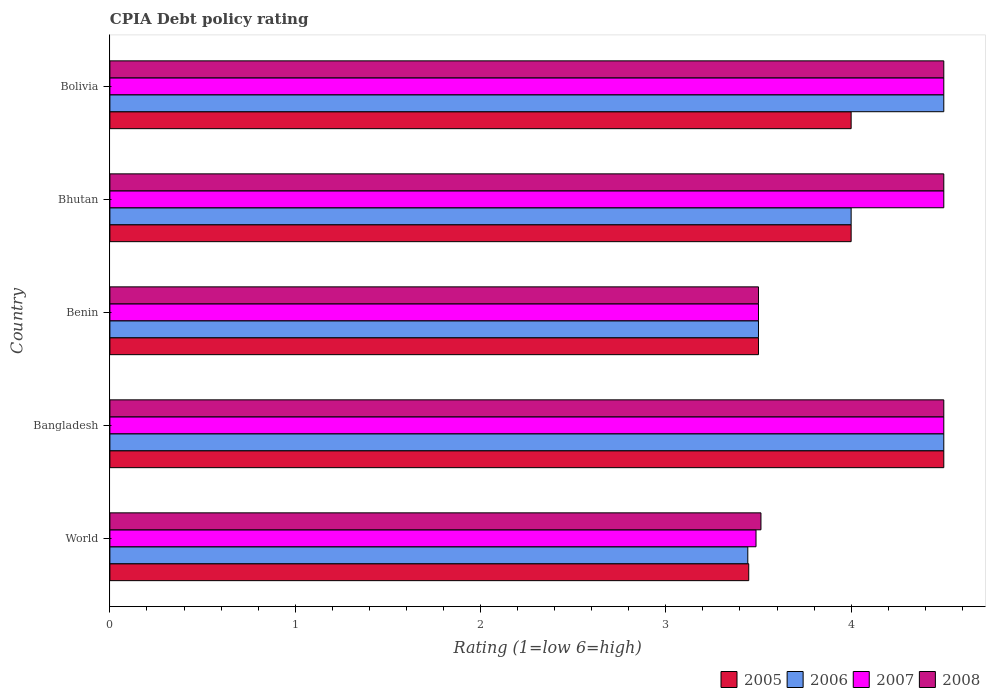How many bars are there on the 4th tick from the bottom?
Make the answer very short. 4. What is the label of the 3rd group of bars from the top?
Offer a very short reply. Benin. Across all countries, what is the minimum CPIA rating in 2005?
Keep it short and to the point. 3.45. In which country was the CPIA rating in 2008 maximum?
Ensure brevity in your answer.  Bangladesh. In which country was the CPIA rating in 2007 minimum?
Ensure brevity in your answer.  World. What is the total CPIA rating in 2007 in the graph?
Ensure brevity in your answer.  20.49. What is the difference between the CPIA rating in 2006 in Benin and that in World?
Offer a terse response. 0.06. What is the difference between the CPIA rating in 2005 in Bangladesh and the CPIA rating in 2007 in World?
Your response must be concise. 1.01. What is the average CPIA rating in 2006 per country?
Your answer should be compact. 3.99. Is the difference between the CPIA rating in 2006 in Bangladesh and Bolivia greater than the difference between the CPIA rating in 2005 in Bangladesh and Bolivia?
Provide a short and direct response. No. What is the difference between the highest and the lowest CPIA rating in 2008?
Offer a terse response. 1. In how many countries, is the CPIA rating in 2005 greater than the average CPIA rating in 2005 taken over all countries?
Make the answer very short. 3. What does the 1st bar from the top in Bangladesh represents?
Give a very brief answer. 2008. Is it the case that in every country, the sum of the CPIA rating in 2008 and CPIA rating in 2005 is greater than the CPIA rating in 2006?
Your answer should be compact. Yes. Are all the bars in the graph horizontal?
Make the answer very short. Yes. How many countries are there in the graph?
Your answer should be very brief. 5. Are the values on the major ticks of X-axis written in scientific E-notation?
Make the answer very short. No. Does the graph contain any zero values?
Offer a very short reply. No. How many legend labels are there?
Your response must be concise. 4. How are the legend labels stacked?
Your answer should be compact. Horizontal. What is the title of the graph?
Your answer should be compact. CPIA Debt policy rating. What is the Rating (1=low 6=high) in 2005 in World?
Your answer should be compact. 3.45. What is the Rating (1=low 6=high) of 2006 in World?
Provide a succinct answer. 3.44. What is the Rating (1=low 6=high) of 2007 in World?
Offer a terse response. 3.49. What is the Rating (1=low 6=high) in 2008 in World?
Your answer should be very brief. 3.51. What is the Rating (1=low 6=high) of 2005 in Bangladesh?
Provide a short and direct response. 4.5. What is the Rating (1=low 6=high) of 2006 in Bangladesh?
Offer a very short reply. 4.5. What is the Rating (1=low 6=high) in 2008 in Bangladesh?
Provide a succinct answer. 4.5. What is the Rating (1=low 6=high) in 2008 in Benin?
Your answer should be compact. 3.5. What is the Rating (1=low 6=high) of 2005 in Bhutan?
Provide a succinct answer. 4. What is the Rating (1=low 6=high) in 2008 in Bhutan?
Your response must be concise. 4.5. What is the Rating (1=low 6=high) in 2005 in Bolivia?
Your response must be concise. 4. What is the Rating (1=low 6=high) of 2006 in Bolivia?
Provide a succinct answer. 4.5. What is the Rating (1=low 6=high) of 2007 in Bolivia?
Your answer should be very brief. 4.5. Across all countries, what is the maximum Rating (1=low 6=high) of 2005?
Your answer should be very brief. 4.5. Across all countries, what is the maximum Rating (1=low 6=high) in 2007?
Your answer should be very brief. 4.5. Across all countries, what is the minimum Rating (1=low 6=high) in 2005?
Offer a very short reply. 3.45. Across all countries, what is the minimum Rating (1=low 6=high) of 2006?
Your answer should be compact. 3.44. Across all countries, what is the minimum Rating (1=low 6=high) in 2007?
Your answer should be very brief. 3.49. Across all countries, what is the minimum Rating (1=low 6=high) in 2008?
Keep it short and to the point. 3.5. What is the total Rating (1=low 6=high) of 2005 in the graph?
Your answer should be very brief. 19.45. What is the total Rating (1=low 6=high) of 2006 in the graph?
Offer a very short reply. 19.94. What is the total Rating (1=low 6=high) in 2007 in the graph?
Offer a terse response. 20.49. What is the total Rating (1=low 6=high) in 2008 in the graph?
Provide a succinct answer. 20.51. What is the difference between the Rating (1=low 6=high) of 2005 in World and that in Bangladesh?
Your response must be concise. -1.05. What is the difference between the Rating (1=low 6=high) of 2006 in World and that in Bangladesh?
Ensure brevity in your answer.  -1.06. What is the difference between the Rating (1=low 6=high) in 2007 in World and that in Bangladesh?
Give a very brief answer. -1.01. What is the difference between the Rating (1=low 6=high) of 2008 in World and that in Bangladesh?
Offer a very short reply. -0.99. What is the difference between the Rating (1=low 6=high) of 2005 in World and that in Benin?
Offer a terse response. -0.05. What is the difference between the Rating (1=low 6=high) in 2006 in World and that in Benin?
Offer a terse response. -0.06. What is the difference between the Rating (1=low 6=high) of 2007 in World and that in Benin?
Offer a terse response. -0.01. What is the difference between the Rating (1=low 6=high) in 2008 in World and that in Benin?
Keep it short and to the point. 0.01. What is the difference between the Rating (1=low 6=high) of 2005 in World and that in Bhutan?
Your answer should be compact. -0.55. What is the difference between the Rating (1=low 6=high) in 2006 in World and that in Bhutan?
Give a very brief answer. -0.56. What is the difference between the Rating (1=low 6=high) of 2007 in World and that in Bhutan?
Ensure brevity in your answer.  -1.01. What is the difference between the Rating (1=low 6=high) of 2008 in World and that in Bhutan?
Your answer should be very brief. -0.99. What is the difference between the Rating (1=low 6=high) of 2005 in World and that in Bolivia?
Your answer should be very brief. -0.55. What is the difference between the Rating (1=low 6=high) of 2006 in World and that in Bolivia?
Your response must be concise. -1.06. What is the difference between the Rating (1=low 6=high) of 2007 in World and that in Bolivia?
Ensure brevity in your answer.  -1.01. What is the difference between the Rating (1=low 6=high) in 2008 in World and that in Bolivia?
Your answer should be compact. -0.99. What is the difference between the Rating (1=low 6=high) in 2006 in Bangladesh and that in Benin?
Your response must be concise. 1. What is the difference between the Rating (1=low 6=high) of 2006 in Bangladesh and that in Bhutan?
Provide a succinct answer. 0.5. What is the difference between the Rating (1=low 6=high) of 2007 in Bangladesh and that in Bhutan?
Give a very brief answer. 0. What is the difference between the Rating (1=low 6=high) of 2008 in Bangladesh and that in Bhutan?
Provide a short and direct response. 0. What is the difference between the Rating (1=low 6=high) of 2005 in Bangladesh and that in Bolivia?
Offer a terse response. 0.5. What is the difference between the Rating (1=low 6=high) of 2005 in Benin and that in Bhutan?
Keep it short and to the point. -0.5. What is the difference between the Rating (1=low 6=high) in 2006 in Benin and that in Bhutan?
Give a very brief answer. -0.5. What is the difference between the Rating (1=low 6=high) in 2007 in Benin and that in Bhutan?
Keep it short and to the point. -1. What is the difference between the Rating (1=low 6=high) in 2006 in Benin and that in Bolivia?
Give a very brief answer. -1. What is the difference between the Rating (1=low 6=high) of 2006 in Bhutan and that in Bolivia?
Make the answer very short. -0.5. What is the difference between the Rating (1=low 6=high) of 2007 in Bhutan and that in Bolivia?
Give a very brief answer. 0. What is the difference between the Rating (1=low 6=high) in 2005 in World and the Rating (1=low 6=high) in 2006 in Bangladesh?
Your response must be concise. -1.05. What is the difference between the Rating (1=low 6=high) of 2005 in World and the Rating (1=low 6=high) of 2007 in Bangladesh?
Provide a short and direct response. -1.05. What is the difference between the Rating (1=low 6=high) of 2005 in World and the Rating (1=low 6=high) of 2008 in Bangladesh?
Your response must be concise. -1.05. What is the difference between the Rating (1=low 6=high) of 2006 in World and the Rating (1=low 6=high) of 2007 in Bangladesh?
Provide a short and direct response. -1.06. What is the difference between the Rating (1=low 6=high) in 2006 in World and the Rating (1=low 6=high) in 2008 in Bangladesh?
Give a very brief answer. -1.06. What is the difference between the Rating (1=low 6=high) of 2007 in World and the Rating (1=low 6=high) of 2008 in Bangladesh?
Your answer should be compact. -1.01. What is the difference between the Rating (1=low 6=high) in 2005 in World and the Rating (1=low 6=high) in 2006 in Benin?
Your answer should be compact. -0.05. What is the difference between the Rating (1=low 6=high) of 2005 in World and the Rating (1=low 6=high) of 2007 in Benin?
Your response must be concise. -0.05. What is the difference between the Rating (1=low 6=high) in 2005 in World and the Rating (1=low 6=high) in 2008 in Benin?
Offer a terse response. -0.05. What is the difference between the Rating (1=low 6=high) in 2006 in World and the Rating (1=low 6=high) in 2007 in Benin?
Provide a short and direct response. -0.06. What is the difference between the Rating (1=low 6=high) in 2006 in World and the Rating (1=low 6=high) in 2008 in Benin?
Make the answer very short. -0.06. What is the difference between the Rating (1=low 6=high) of 2007 in World and the Rating (1=low 6=high) of 2008 in Benin?
Your answer should be very brief. -0.01. What is the difference between the Rating (1=low 6=high) in 2005 in World and the Rating (1=low 6=high) in 2006 in Bhutan?
Your response must be concise. -0.55. What is the difference between the Rating (1=low 6=high) of 2005 in World and the Rating (1=low 6=high) of 2007 in Bhutan?
Make the answer very short. -1.05. What is the difference between the Rating (1=low 6=high) in 2005 in World and the Rating (1=low 6=high) in 2008 in Bhutan?
Ensure brevity in your answer.  -1.05. What is the difference between the Rating (1=low 6=high) of 2006 in World and the Rating (1=low 6=high) of 2007 in Bhutan?
Provide a succinct answer. -1.06. What is the difference between the Rating (1=low 6=high) of 2006 in World and the Rating (1=low 6=high) of 2008 in Bhutan?
Provide a succinct answer. -1.06. What is the difference between the Rating (1=low 6=high) of 2007 in World and the Rating (1=low 6=high) of 2008 in Bhutan?
Your answer should be compact. -1.01. What is the difference between the Rating (1=low 6=high) of 2005 in World and the Rating (1=low 6=high) of 2006 in Bolivia?
Provide a succinct answer. -1.05. What is the difference between the Rating (1=low 6=high) in 2005 in World and the Rating (1=low 6=high) in 2007 in Bolivia?
Give a very brief answer. -1.05. What is the difference between the Rating (1=low 6=high) in 2005 in World and the Rating (1=low 6=high) in 2008 in Bolivia?
Provide a succinct answer. -1.05. What is the difference between the Rating (1=low 6=high) of 2006 in World and the Rating (1=low 6=high) of 2007 in Bolivia?
Keep it short and to the point. -1.06. What is the difference between the Rating (1=low 6=high) in 2006 in World and the Rating (1=low 6=high) in 2008 in Bolivia?
Keep it short and to the point. -1.06. What is the difference between the Rating (1=low 6=high) in 2007 in World and the Rating (1=low 6=high) in 2008 in Bolivia?
Ensure brevity in your answer.  -1.01. What is the difference between the Rating (1=low 6=high) in 2005 in Bangladesh and the Rating (1=low 6=high) in 2006 in Benin?
Offer a terse response. 1. What is the difference between the Rating (1=low 6=high) in 2005 in Bangladesh and the Rating (1=low 6=high) in 2007 in Benin?
Ensure brevity in your answer.  1. What is the difference between the Rating (1=low 6=high) of 2006 in Bangladesh and the Rating (1=low 6=high) of 2007 in Benin?
Your answer should be very brief. 1. What is the difference between the Rating (1=low 6=high) in 2005 in Bangladesh and the Rating (1=low 6=high) in 2007 in Bhutan?
Provide a succinct answer. 0. What is the difference between the Rating (1=low 6=high) of 2005 in Bangladesh and the Rating (1=low 6=high) of 2008 in Bhutan?
Provide a succinct answer. 0. What is the difference between the Rating (1=low 6=high) of 2007 in Bangladesh and the Rating (1=low 6=high) of 2008 in Bhutan?
Your response must be concise. 0. What is the difference between the Rating (1=low 6=high) of 2005 in Bangladesh and the Rating (1=low 6=high) of 2008 in Bolivia?
Keep it short and to the point. 0. What is the difference between the Rating (1=low 6=high) in 2006 in Bangladesh and the Rating (1=low 6=high) in 2007 in Bolivia?
Your answer should be compact. 0. What is the difference between the Rating (1=low 6=high) in 2006 in Bangladesh and the Rating (1=low 6=high) in 2008 in Bolivia?
Provide a short and direct response. 0. What is the difference between the Rating (1=low 6=high) in 2005 in Benin and the Rating (1=low 6=high) in 2006 in Bhutan?
Your response must be concise. -0.5. What is the difference between the Rating (1=low 6=high) of 2005 in Benin and the Rating (1=low 6=high) of 2007 in Bhutan?
Make the answer very short. -1. What is the difference between the Rating (1=low 6=high) of 2005 in Benin and the Rating (1=low 6=high) of 2008 in Bhutan?
Offer a very short reply. -1. What is the difference between the Rating (1=low 6=high) of 2007 in Benin and the Rating (1=low 6=high) of 2008 in Bhutan?
Your answer should be compact. -1. What is the difference between the Rating (1=low 6=high) of 2005 in Benin and the Rating (1=low 6=high) of 2007 in Bolivia?
Your response must be concise. -1. What is the difference between the Rating (1=low 6=high) in 2005 in Benin and the Rating (1=low 6=high) in 2008 in Bolivia?
Give a very brief answer. -1. What is the difference between the Rating (1=low 6=high) in 2007 in Benin and the Rating (1=low 6=high) in 2008 in Bolivia?
Your answer should be very brief. -1. What is the difference between the Rating (1=low 6=high) in 2005 in Bhutan and the Rating (1=low 6=high) in 2006 in Bolivia?
Offer a terse response. -0.5. What is the difference between the Rating (1=low 6=high) in 2005 in Bhutan and the Rating (1=low 6=high) in 2007 in Bolivia?
Make the answer very short. -0.5. What is the difference between the Rating (1=low 6=high) in 2005 in Bhutan and the Rating (1=low 6=high) in 2008 in Bolivia?
Your answer should be very brief. -0.5. What is the difference between the Rating (1=low 6=high) in 2006 in Bhutan and the Rating (1=low 6=high) in 2008 in Bolivia?
Provide a succinct answer. -0.5. What is the difference between the Rating (1=low 6=high) of 2007 in Bhutan and the Rating (1=low 6=high) of 2008 in Bolivia?
Your response must be concise. 0. What is the average Rating (1=low 6=high) of 2005 per country?
Ensure brevity in your answer.  3.89. What is the average Rating (1=low 6=high) of 2006 per country?
Your answer should be very brief. 3.99. What is the average Rating (1=low 6=high) in 2007 per country?
Offer a very short reply. 4.1. What is the average Rating (1=low 6=high) of 2008 per country?
Ensure brevity in your answer.  4.1. What is the difference between the Rating (1=low 6=high) in 2005 and Rating (1=low 6=high) in 2006 in World?
Make the answer very short. 0.01. What is the difference between the Rating (1=low 6=high) in 2005 and Rating (1=low 6=high) in 2007 in World?
Offer a terse response. -0.04. What is the difference between the Rating (1=low 6=high) in 2005 and Rating (1=low 6=high) in 2008 in World?
Your answer should be very brief. -0.07. What is the difference between the Rating (1=low 6=high) in 2006 and Rating (1=low 6=high) in 2007 in World?
Your answer should be compact. -0.04. What is the difference between the Rating (1=low 6=high) of 2006 and Rating (1=low 6=high) of 2008 in World?
Your response must be concise. -0.07. What is the difference between the Rating (1=low 6=high) in 2007 and Rating (1=low 6=high) in 2008 in World?
Make the answer very short. -0.03. What is the difference between the Rating (1=low 6=high) of 2006 and Rating (1=low 6=high) of 2008 in Bangladesh?
Your answer should be compact. 0. What is the difference between the Rating (1=low 6=high) of 2005 and Rating (1=low 6=high) of 2007 in Benin?
Make the answer very short. 0. What is the difference between the Rating (1=low 6=high) of 2005 and Rating (1=low 6=high) of 2008 in Benin?
Provide a succinct answer. 0. What is the difference between the Rating (1=low 6=high) in 2005 and Rating (1=low 6=high) in 2007 in Bhutan?
Offer a very short reply. -0.5. What is the difference between the Rating (1=low 6=high) in 2005 and Rating (1=low 6=high) in 2008 in Bhutan?
Ensure brevity in your answer.  -0.5. What is the difference between the Rating (1=low 6=high) of 2007 and Rating (1=low 6=high) of 2008 in Bolivia?
Your response must be concise. 0. What is the ratio of the Rating (1=low 6=high) of 2005 in World to that in Bangladesh?
Keep it short and to the point. 0.77. What is the ratio of the Rating (1=low 6=high) in 2006 in World to that in Bangladesh?
Offer a very short reply. 0.77. What is the ratio of the Rating (1=low 6=high) of 2007 in World to that in Bangladesh?
Your answer should be very brief. 0.77. What is the ratio of the Rating (1=low 6=high) in 2008 in World to that in Bangladesh?
Provide a succinct answer. 0.78. What is the ratio of the Rating (1=low 6=high) of 2006 in World to that in Benin?
Your response must be concise. 0.98. What is the ratio of the Rating (1=low 6=high) in 2008 in World to that in Benin?
Offer a very short reply. 1. What is the ratio of the Rating (1=low 6=high) in 2005 in World to that in Bhutan?
Your answer should be compact. 0.86. What is the ratio of the Rating (1=low 6=high) of 2006 in World to that in Bhutan?
Your answer should be very brief. 0.86. What is the ratio of the Rating (1=low 6=high) of 2007 in World to that in Bhutan?
Provide a short and direct response. 0.77. What is the ratio of the Rating (1=low 6=high) in 2008 in World to that in Bhutan?
Keep it short and to the point. 0.78. What is the ratio of the Rating (1=low 6=high) in 2005 in World to that in Bolivia?
Provide a succinct answer. 0.86. What is the ratio of the Rating (1=low 6=high) of 2006 in World to that in Bolivia?
Offer a very short reply. 0.77. What is the ratio of the Rating (1=low 6=high) of 2007 in World to that in Bolivia?
Offer a very short reply. 0.77. What is the ratio of the Rating (1=low 6=high) in 2008 in World to that in Bolivia?
Provide a short and direct response. 0.78. What is the ratio of the Rating (1=low 6=high) of 2005 in Bangladesh to that in Bhutan?
Ensure brevity in your answer.  1.12. What is the ratio of the Rating (1=low 6=high) in 2006 in Bangladesh to that in Bhutan?
Your answer should be very brief. 1.12. What is the ratio of the Rating (1=low 6=high) in 2005 in Bangladesh to that in Bolivia?
Your answer should be compact. 1.12. What is the ratio of the Rating (1=low 6=high) in 2006 in Bangladesh to that in Bolivia?
Keep it short and to the point. 1. What is the ratio of the Rating (1=low 6=high) in 2007 in Bangladesh to that in Bolivia?
Give a very brief answer. 1. What is the ratio of the Rating (1=low 6=high) in 2008 in Bangladesh to that in Bolivia?
Keep it short and to the point. 1. What is the ratio of the Rating (1=low 6=high) of 2005 in Benin to that in Bhutan?
Ensure brevity in your answer.  0.88. What is the ratio of the Rating (1=low 6=high) in 2005 in Benin to that in Bolivia?
Make the answer very short. 0.88. What is the ratio of the Rating (1=low 6=high) of 2006 in Benin to that in Bolivia?
Provide a succinct answer. 0.78. What is the ratio of the Rating (1=low 6=high) of 2007 in Benin to that in Bolivia?
Provide a short and direct response. 0.78. What is the ratio of the Rating (1=low 6=high) in 2008 in Benin to that in Bolivia?
Offer a very short reply. 0.78. What is the difference between the highest and the second highest Rating (1=low 6=high) in 2005?
Your answer should be very brief. 0.5. What is the difference between the highest and the second highest Rating (1=low 6=high) in 2006?
Provide a short and direct response. 0. What is the difference between the highest and the lowest Rating (1=low 6=high) of 2005?
Provide a succinct answer. 1.05. What is the difference between the highest and the lowest Rating (1=low 6=high) of 2006?
Your answer should be compact. 1.06. What is the difference between the highest and the lowest Rating (1=low 6=high) in 2007?
Make the answer very short. 1.01. 